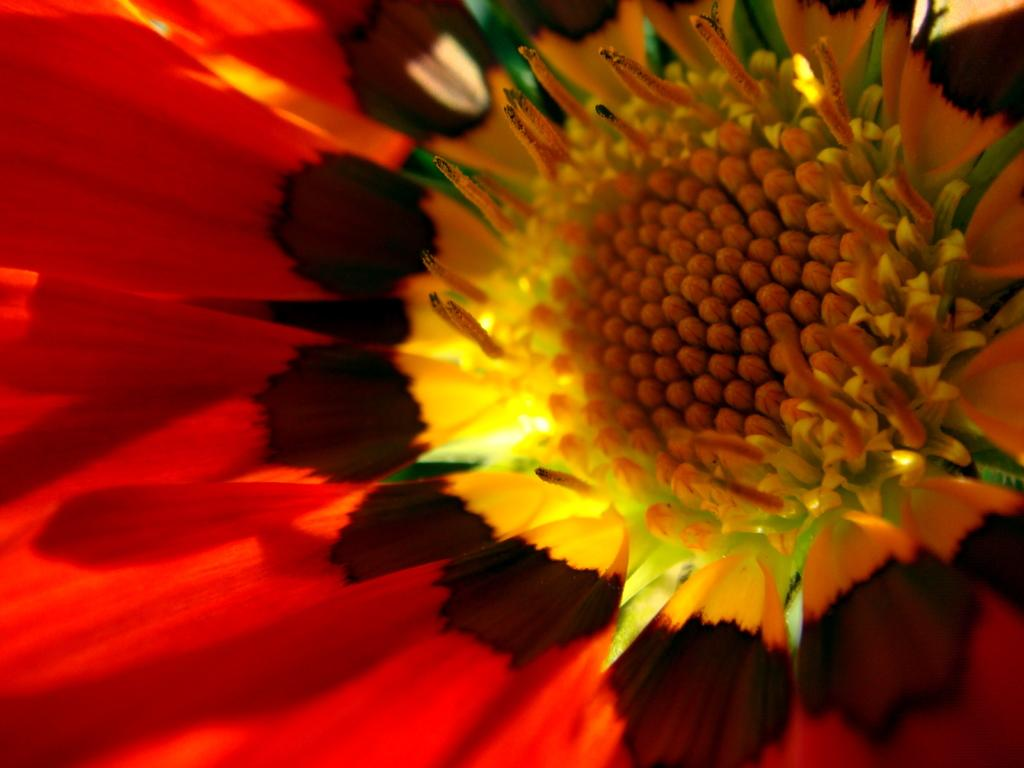What is the main subject of the image? There is a flower in the image. What type of jam is spread on the beetle in the image? There is no beetle or jam present in the image; it only features a flower. 